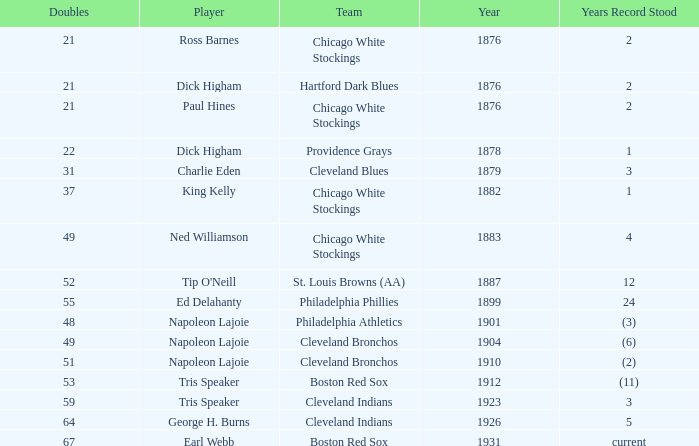What year did napoleon lajoie, playing for the cleveland bronchos, establish the record of 49 doubles? (6). 